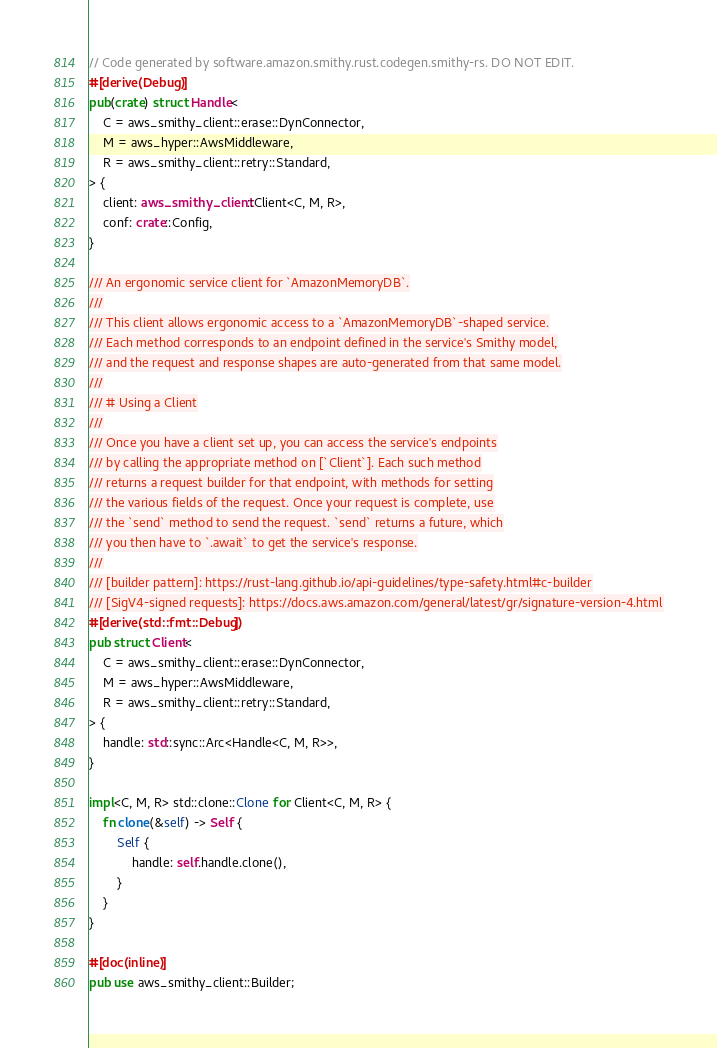Convert code to text. <code><loc_0><loc_0><loc_500><loc_500><_Rust_>// Code generated by software.amazon.smithy.rust.codegen.smithy-rs. DO NOT EDIT.
#[derive(Debug)]
pub(crate) struct Handle<
    C = aws_smithy_client::erase::DynConnector,
    M = aws_hyper::AwsMiddleware,
    R = aws_smithy_client::retry::Standard,
> {
    client: aws_smithy_client::Client<C, M, R>,
    conf: crate::Config,
}

/// An ergonomic service client for `AmazonMemoryDB`.
///
/// This client allows ergonomic access to a `AmazonMemoryDB`-shaped service.
/// Each method corresponds to an endpoint defined in the service's Smithy model,
/// and the request and response shapes are auto-generated from that same model.
///
/// # Using a Client
///
/// Once you have a client set up, you can access the service's endpoints
/// by calling the appropriate method on [`Client`]. Each such method
/// returns a request builder for that endpoint, with methods for setting
/// the various fields of the request. Once your request is complete, use
/// the `send` method to send the request. `send` returns a future, which
/// you then have to `.await` to get the service's response.
///
/// [builder pattern]: https://rust-lang.github.io/api-guidelines/type-safety.html#c-builder
/// [SigV4-signed requests]: https://docs.aws.amazon.com/general/latest/gr/signature-version-4.html
#[derive(std::fmt::Debug)]
pub struct Client<
    C = aws_smithy_client::erase::DynConnector,
    M = aws_hyper::AwsMiddleware,
    R = aws_smithy_client::retry::Standard,
> {
    handle: std::sync::Arc<Handle<C, M, R>>,
}

impl<C, M, R> std::clone::Clone for Client<C, M, R> {
    fn clone(&self) -> Self {
        Self {
            handle: self.handle.clone(),
        }
    }
}

#[doc(inline)]
pub use aws_smithy_client::Builder;
</code> 